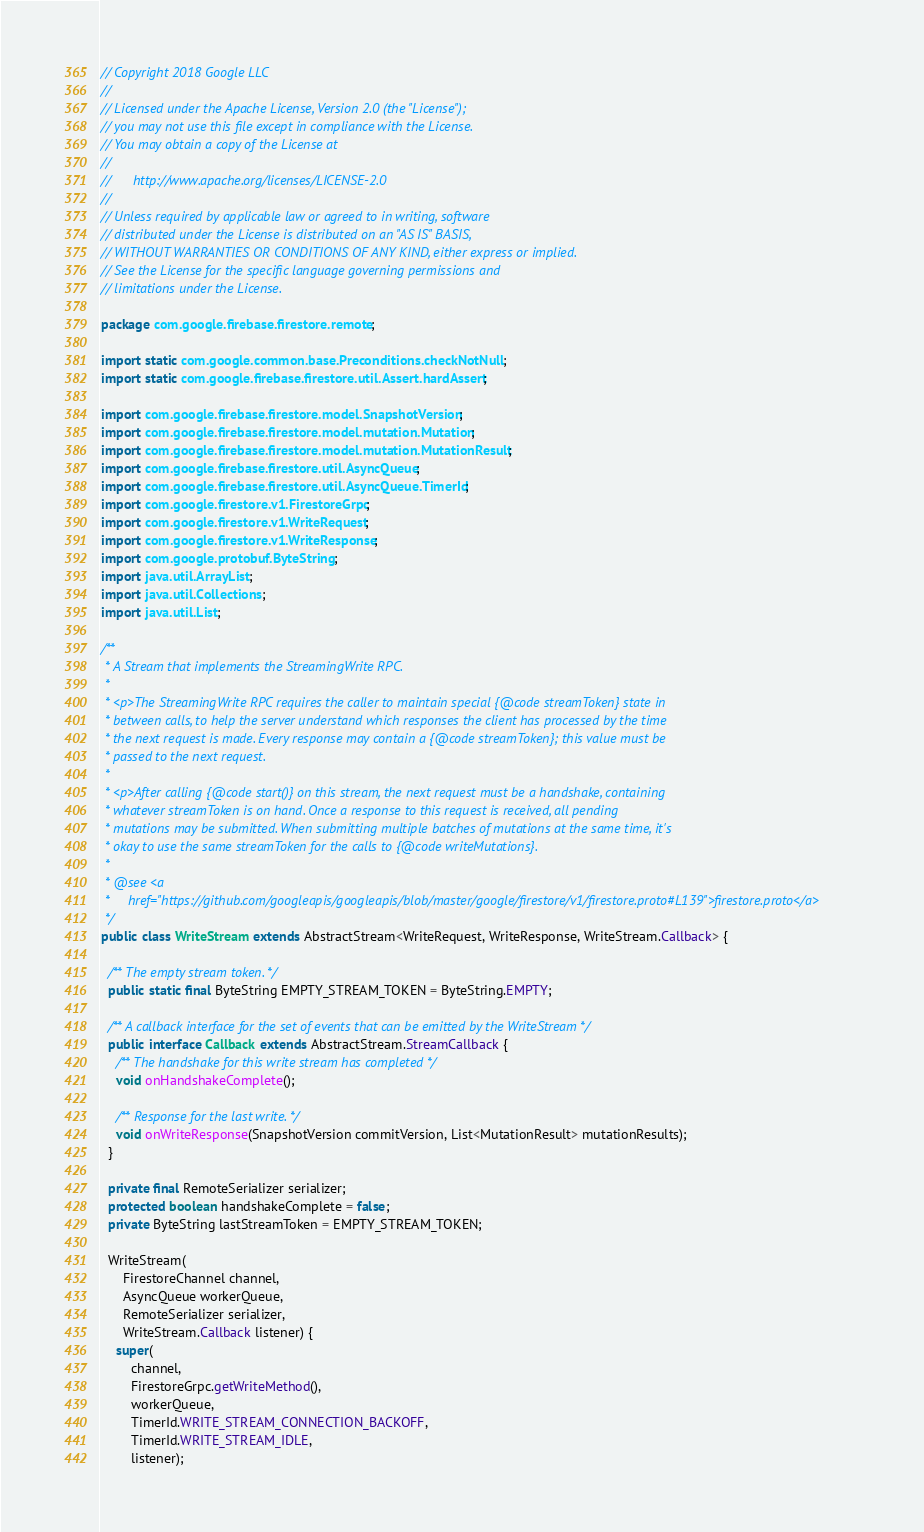Convert code to text. <code><loc_0><loc_0><loc_500><loc_500><_Java_>// Copyright 2018 Google LLC
//
// Licensed under the Apache License, Version 2.0 (the "License");
// you may not use this file except in compliance with the License.
// You may obtain a copy of the License at
//
//      http://www.apache.org/licenses/LICENSE-2.0
//
// Unless required by applicable law or agreed to in writing, software
// distributed under the License is distributed on an "AS IS" BASIS,
// WITHOUT WARRANTIES OR CONDITIONS OF ANY KIND, either express or implied.
// See the License for the specific language governing permissions and
// limitations under the License.

package com.google.firebase.firestore.remote;

import static com.google.common.base.Preconditions.checkNotNull;
import static com.google.firebase.firestore.util.Assert.hardAssert;

import com.google.firebase.firestore.model.SnapshotVersion;
import com.google.firebase.firestore.model.mutation.Mutation;
import com.google.firebase.firestore.model.mutation.MutationResult;
import com.google.firebase.firestore.util.AsyncQueue;
import com.google.firebase.firestore.util.AsyncQueue.TimerId;
import com.google.firestore.v1.FirestoreGrpc;
import com.google.firestore.v1.WriteRequest;
import com.google.firestore.v1.WriteResponse;
import com.google.protobuf.ByteString;
import java.util.ArrayList;
import java.util.Collections;
import java.util.List;

/**
 * A Stream that implements the StreamingWrite RPC.
 *
 * <p>The StreamingWrite RPC requires the caller to maintain special {@code streamToken} state in
 * between calls, to help the server understand which responses the client has processed by the time
 * the next request is made. Every response may contain a {@code streamToken}; this value must be
 * passed to the next request.
 *
 * <p>After calling {@code start()} on this stream, the next request must be a handshake, containing
 * whatever streamToken is on hand. Once a response to this request is received, all pending
 * mutations may be submitted. When submitting multiple batches of mutations at the same time, it's
 * okay to use the same streamToken for the calls to {@code writeMutations}.
 *
 * @see <a
 *     href="https://github.com/googleapis/googleapis/blob/master/google/firestore/v1/firestore.proto#L139">firestore.proto</a>
 */
public class WriteStream extends AbstractStream<WriteRequest, WriteResponse, WriteStream.Callback> {

  /** The empty stream token. */
  public static final ByteString EMPTY_STREAM_TOKEN = ByteString.EMPTY;

  /** A callback interface for the set of events that can be emitted by the WriteStream */
  public interface Callback extends AbstractStream.StreamCallback {
    /** The handshake for this write stream has completed */
    void onHandshakeComplete();

    /** Response for the last write. */
    void onWriteResponse(SnapshotVersion commitVersion, List<MutationResult> mutationResults);
  }

  private final RemoteSerializer serializer;
  protected boolean handshakeComplete = false;
  private ByteString lastStreamToken = EMPTY_STREAM_TOKEN;

  WriteStream(
      FirestoreChannel channel,
      AsyncQueue workerQueue,
      RemoteSerializer serializer,
      WriteStream.Callback listener) {
    super(
        channel,
        FirestoreGrpc.getWriteMethod(),
        workerQueue,
        TimerId.WRITE_STREAM_CONNECTION_BACKOFF,
        TimerId.WRITE_STREAM_IDLE,
        listener);</code> 